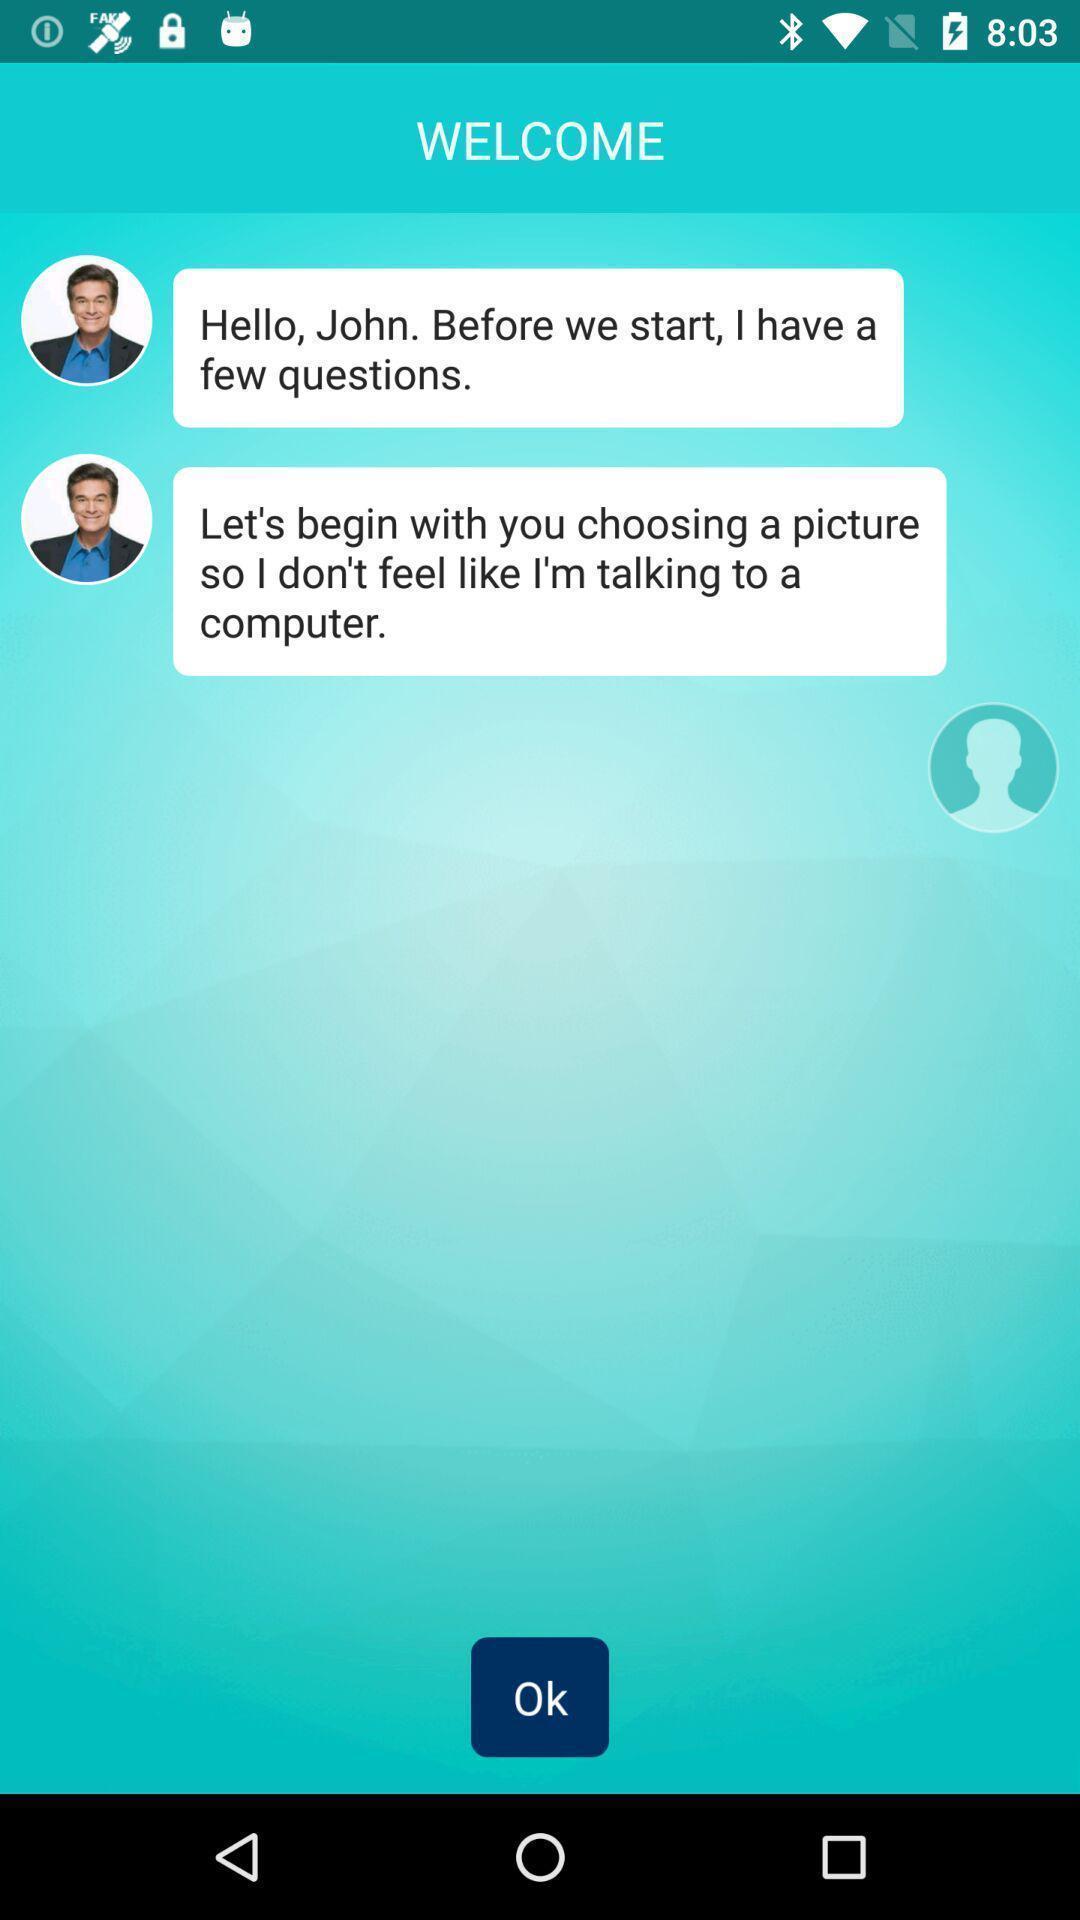Describe the key features of this screenshot. Welcome page of the chat app with some texts. 